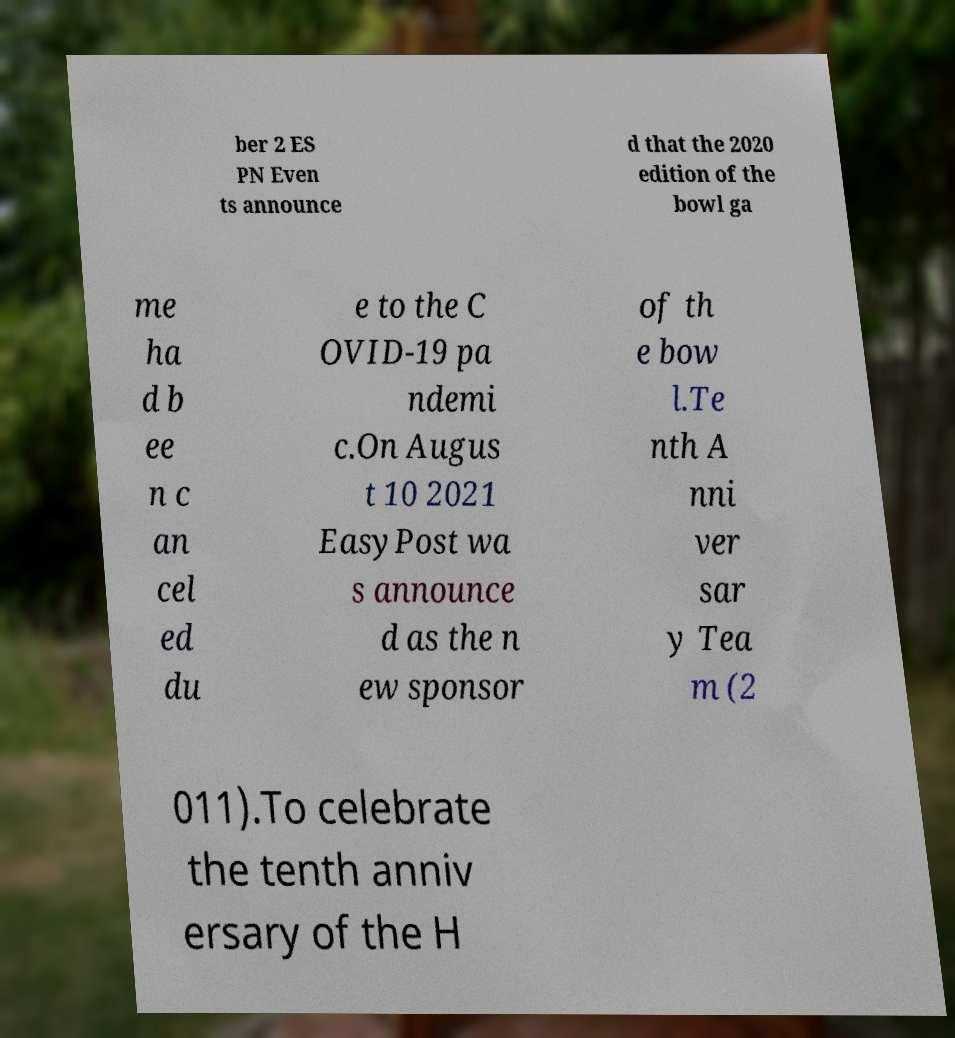There's text embedded in this image that I need extracted. Can you transcribe it verbatim? ber 2 ES PN Even ts announce d that the 2020 edition of the bowl ga me ha d b ee n c an cel ed du e to the C OVID-19 pa ndemi c.On Augus t 10 2021 EasyPost wa s announce d as the n ew sponsor of th e bow l.Te nth A nni ver sar y Tea m (2 011).To celebrate the tenth anniv ersary of the H 